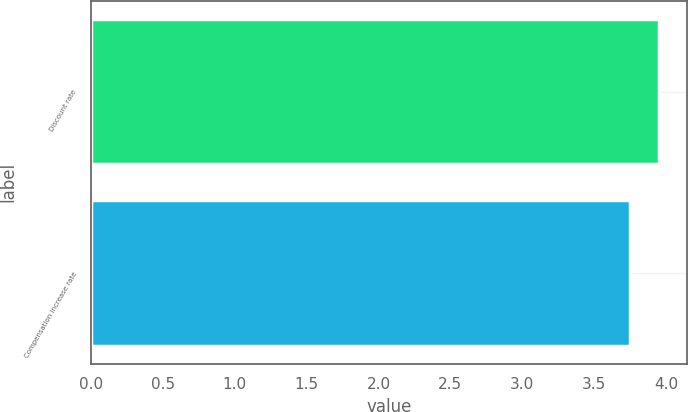<chart> <loc_0><loc_0><loc_500><loc_500><bar_chart><fcel>Discount rate<fcel>Compensation increase rate<nl><fcel>3.95<fcel>3.75<nl></chart> 